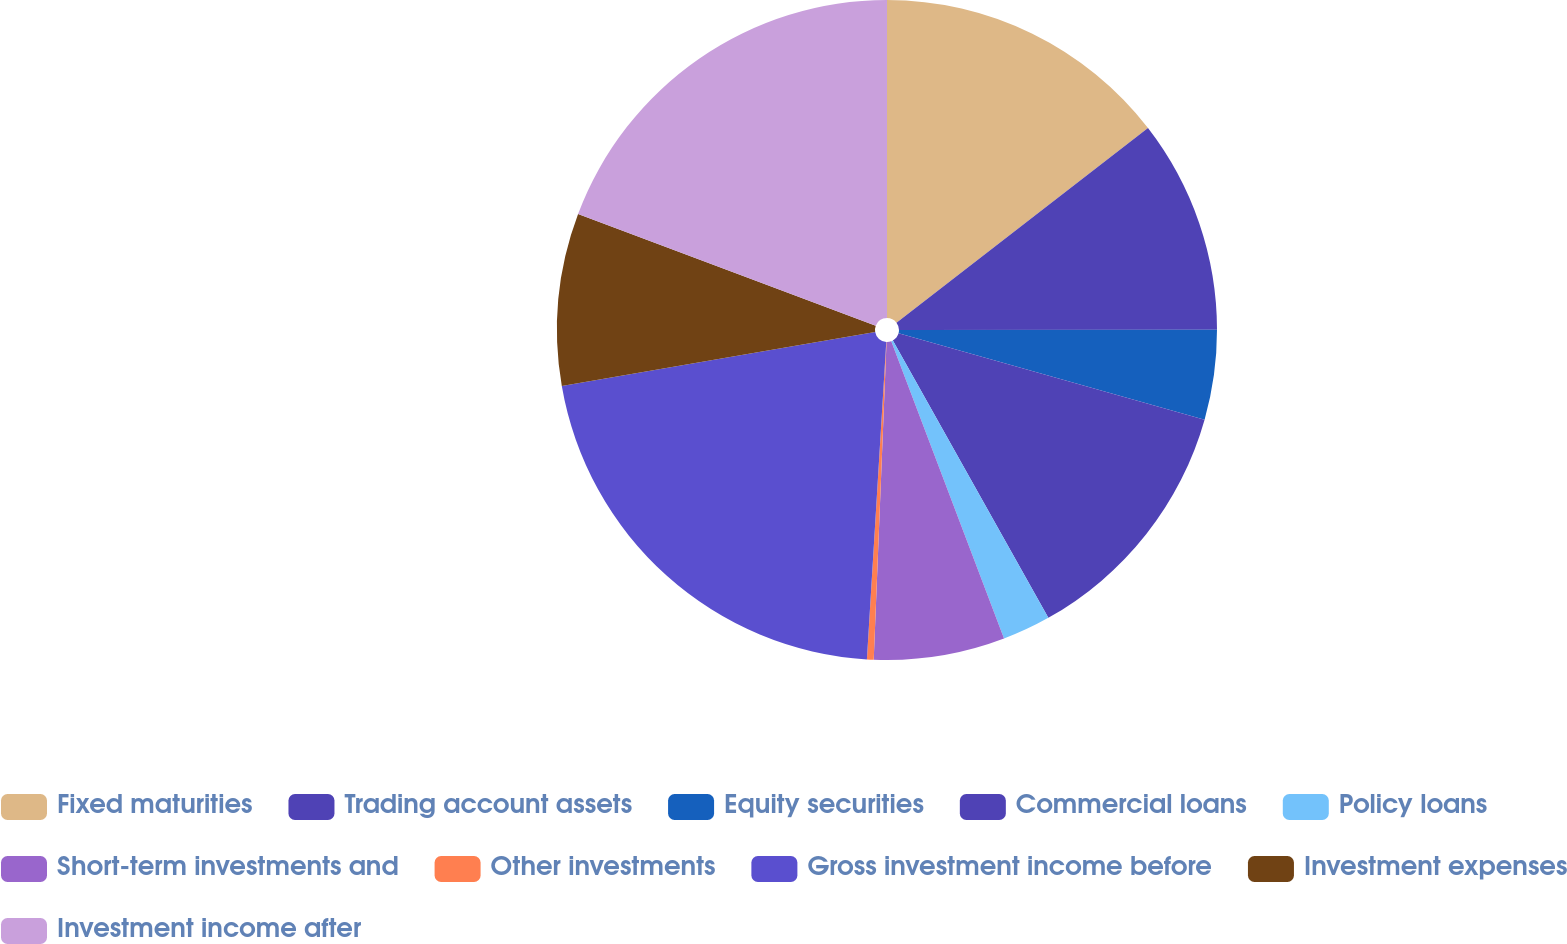<chart> <loc_0><loc_0><loc_500><loc_500><pie_chart><fcel>Fixed maturities<fcel>Trading account assets<fcel>Equity securities<fcel>Commercial loans<fcel>Policy loans<fcel>Short-term investments and<fcel>Other investments<fcel>Gross investment income before<fcel>Investment expenses<fcel>Investment income after<nl><fcel>14.52%<fcel>10.47%<fcel>4.39%<fcel>12.49%<fcel>2.36%<fcel>6.41%<fcel>0.33%<fcel>21.31%<fcel>8.44%<fcel>19.28%<nl></chart> 